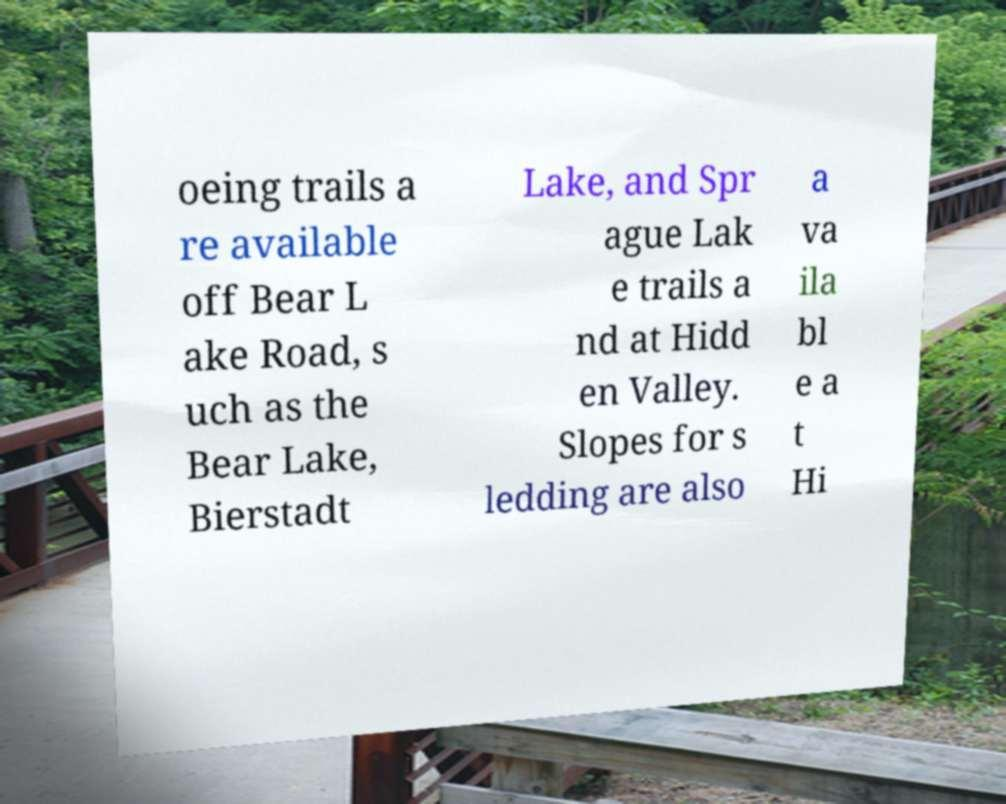There's text embedded in this image that I need extracted. Can you transcribe it verbatim? oeing trails a re available off Bear L ake Road, s uch as the Bear Lake, Bierstadt Lake, and Spr ague Lak e trails a nd at Hidd en Valley. Slopes for s ledding are also a va ila bl e a t Hi 